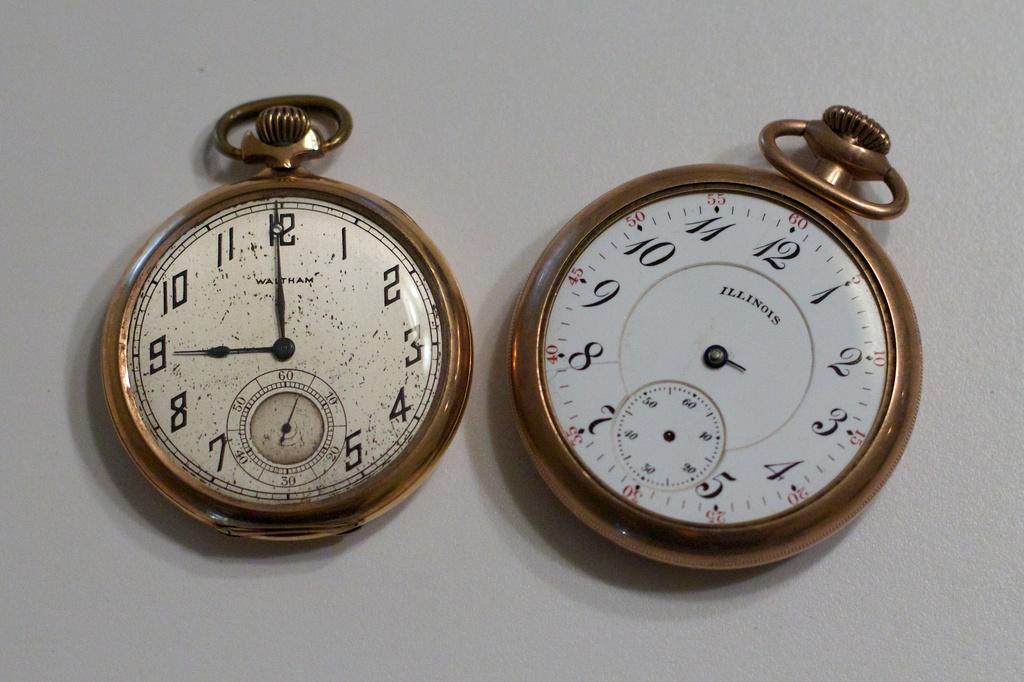What number is the very small hand pointing to on the watch to the right?
Your answer should be very brief. 3. What state is on the right watch?
Offer a terse response. Illinois. 